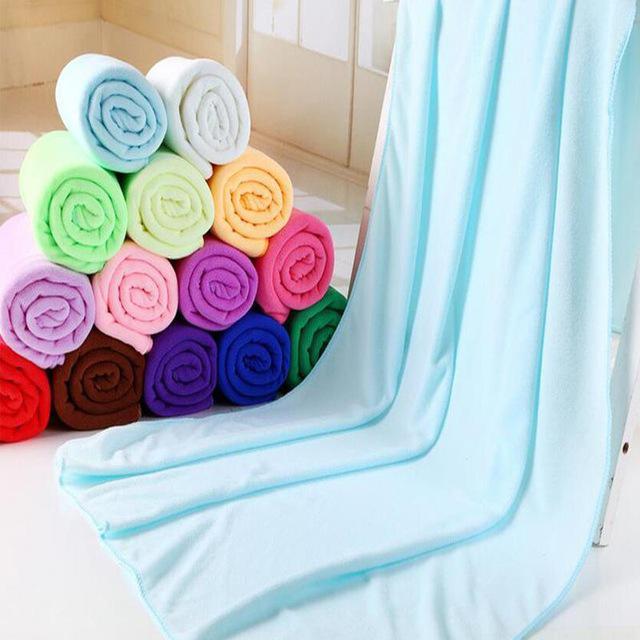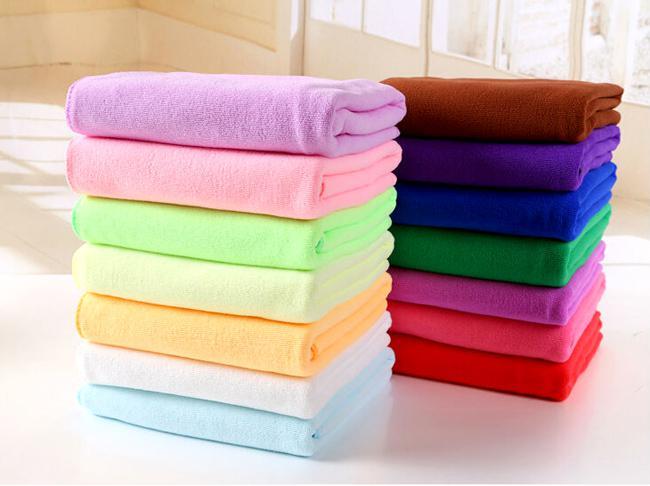The first image is the image on the left, the second image is the image on the right. For the images displayed, is the sentence "Towels in one image, each of them a different color, are folded into neat stacked squares." factually correct? Answer yes or no. Yes. The first image is the image on the left, the second image is the image on the right. Given the left and right images, does the statement "The towels on the right side image are rolled up." hold true? Answer yes or no. No. 